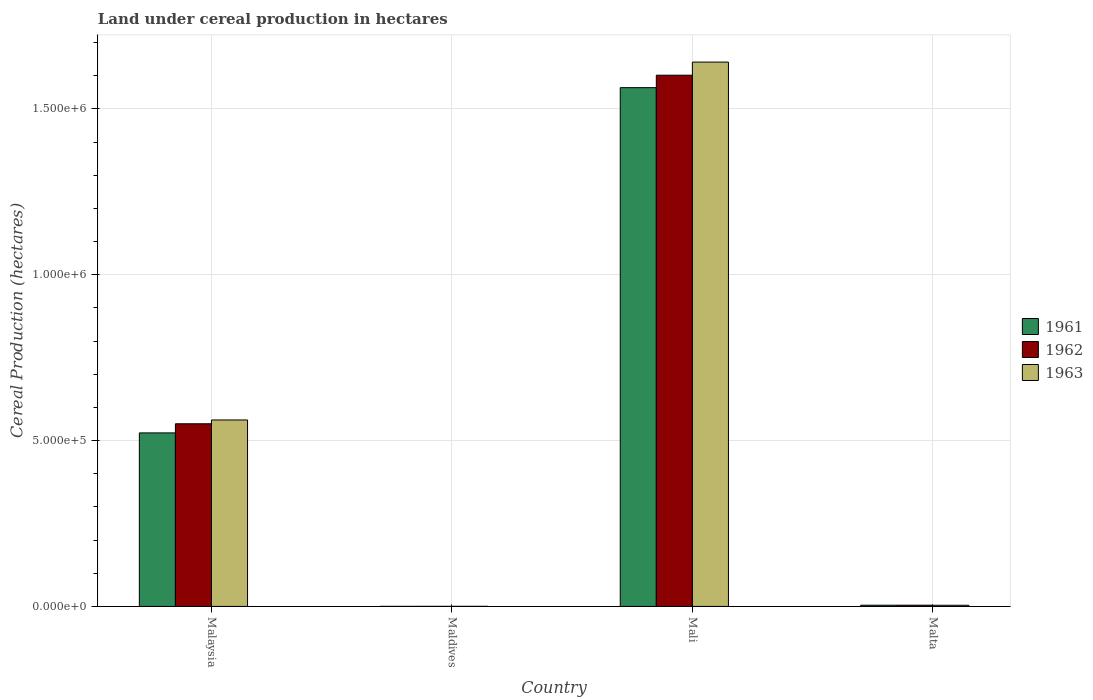Are the number of bars on each tick of the X-axis equal?
Offer a terse response. Yes. How many bars are there on the 3rd tick from the right?
Your answer should be compact. 3. What is the label of the 3rd group of bars from the left?
Make the answer very short. Mali. What is the land under cereal production in 1962 in Mali?
Your answer should be compact. 1.60e+06. Across all countries, what is the maximum land under cereal production in 1963?
Ensure brevity in your answer.  1.64e+06. Across all countries, what is the minimum land under cereal production in 1963?
Offer a very short reply. 292. In which country was the land under cereal production in 1962 maximum?
Offer a terse response. Mali. In which country was the land under cereal production in 1961 minimum?
Offer a terse response. Maldives. What is the total land under cereal production in 1962 in the graph?
Your response must be concise. 2.16e+06. What is the difference between the land under cereal production in 1963 in Malaysia and that in Malta?
Offer a very short reply. 5.59e+05. What is the difference between the land under cereal production in 1961 in Malaysia and the land under cereal production in 1963 in Mali?
Keep it short and to the point. -1.12e+06. What is the average land under cereal production in 1963 per country?
Make the answer very short. 5.52e+05. What is the difference between the land under cereal production of/in 1963 and land under cereal production of/in 1961 in Malaysia?
Provide a succinct answer. 3.90e+04. In how many countries, is the land under cereal production in 1962 greater than 600000 hectares?
Your answer should be very brief. 1. What is the ratio of the land under cereal production in 1961 in Maldives to that in Malta?
Give a very brief answer. 0.05. Is the land under cereal production in 1961 in Malaysia less than that in Mali?
Give a very brief answer. Yes. Is the difference between the land under cereal production in 1963 in Malaysia and Malta greater than the difference between the land under cereal production in 1961 in Malaysia and Malta?
Offer a very short reply. Yes. What is the difference between the highest and the second highest land under cereal production in 1961?
Make the answer very short. -5.20e+05. What is the difference between the highest and the lowest land under cereal production in 1963?
Keep it short and to the point. 1.64e+06. In how many countries, is the land under cereal production in 1961 greater than the average land under cereal production in 1961 taken over all countries?
Offer a terse response. 2. What does the 1st bar from the right in Maldives represents?
Make the answer very short. 1963. Is it the case that in every country, the sum of the land under cereal production in 1963 and land under cereal production in 1962 is greater than the land under cereal production in 1961?
Your answer should be very brief. Yes. Are all the bars in the graph horizontal?
Make the answer very short. No. How many countries are there in the graph?
Ensure brevity in your answer.  4. Does the graph contain any zero values?
Keep it short and to the point. No. How many legend labels are there?
Your response must be concise. 3. What is the title of the graph?
Your answer should be very brief. Land under cereal production in hectares. What is the label or title of the Y-axis?
Offer a very short reply. Cereal Production (hectares). What is the Cereal Production (hectares) of 1961 in Malaysia?
Ensure brevity in your answer.  5.23e+05. What is the Cereal Production (hectares) of 1962 in Malaysia?
Ensure brevity in your answer.  5.51e+05. What is the Cereal Production (hectares) of 1963 in Malaysia?
Offer a terse response. 5.62e+05. What is the Cereal Production (hectares) in 1961 in Maldives?
Give a very brief answer. 179. What is the Cereal Production (hectares) of 1962 in Maldives?
Provide a succinct answer. 240. What is the Cereal Production (hectares) of 1963 in Maldives?
Keep it short and to the point. 292. What is the Cereal Production (hectares) of 1961 in Mali?
Ensure brevity in your answer.  1.56e+06. What is the Cereal Production (hectares) of 1962 in Mali?
Give a very brief answer. 1.60e+06. What is the Cereal Production (hectares) in 1963 in Mali?
Keep it short and to the point. 1.64e+06. What is the Cereal Production (hectares) in 1961 in Malta?
Your response must be concise. 3649. What is the Cereal Production (hectares) of 1962 in Malta?
Your response must be concise. 3699. What is the Cereal Production (hectares) of 1963 in Malta?
Give a very brief answer. 3513. Across all countries, what is the maximum Cereal Production (hectares) in 1961?
Provide a succinct answer. 1.56e+06. Across all countries, what is the maximum Cereal Production (hectares) in 1962?
Offer a terse response. 1.60e+06. Across all countries, what is the maximum Cereal Production (hectares) in 1963?
Provide a short and direct response. 1.64e+06. Across all countries, what is the minimum Cereal Production (hectares) in 1961?
Your answer should be compact. 179. Across all countries, what is the minimum Cereal Production (hectares) of 1962?
Offer a very short reply. 240. Across all countries, what is the minimum Cereal Production (hectares) in 1963?
Offer a very short reply. 292. What is the total Cereal Production (hectares) of 1961 in the graph?
Your response must be concise. 2.09e+06. What is the total Cereal Production (hectares) of 1962 in the graph?
Make the answer very short. 2.16e+06. What is the total Cereal Production (hectares) in 1963 in the graph?
Your answer should be compact. 2.21e+06. What is the difference between the Cereal Production (hectares) in 1961 in Malaysia and that in Maldives?
Provide a succinct answer. 5.23e+05. What is the difference between the Cereal Production (hectares) in 1962 in Malaysia and that in Maldives?
Make the answer very short. 5.50e+05. What is the difference between the Cereal Production (hectares) of 1963 in Malaysia and that in Maldives?
Your answer should be very brief. 5.62e+05. What is the difference between the Cereal Production (hectares) of 1961 in Malaysia and that in Mali?
Offer a terse response. -1.04e+06. What is the difference between the Cereal Production (hectares) of 1962 in Malaysia and that in Mali?
Your answer should be very brief. -1.05e+06. What is the difference between the Cereal Production (hectares) of 1963 in Malaysia and that in Mali?
Your answer should be very brief. -1.08e+06. What is the difference between the Cereal Production (hectares) in 1961 in Malaysia and that in Malta?
Your answer should be very brief. 5.20e+05. What is the difference between the Cereal Production (hectares) of 1962 in Malaysia and that in Malta?
Offer a very short reply. 5.47e+05. What is the difference between the Cereal Production (hectares) in 1963 in Malaysia and that in Malta?
Keep it short and to the point. 5.59e+05. What is the difference between the Cereal Production (hectares) of 1961 in Maldives and that in Mali?
Keep it short and to the point. -1.56e+06. What is the difference between the Cereal Production (hectares) in 1962 in Maldives and that in Mali?
Offer a very short reply. -1.60e+06. What is the difference between the Cereal Production (hectares) of 1963 in Maldives and that in Mali?
Offer a terse response. -1.64e+06. What is the difference between the Cereal Production (hectares) in 1961 in Maldives and that in Malta?
Ensure brevity in your answer.  -3470. What is the difference between the Cereal Production (hectares) in 1962 in Maldives and that in Malta?
Your response must be concise. -3459. What is the difference between the Cereal Production (hectares) in 1963 in Maldives and that in Malta?
Your answer should be very brief. -3221. What is the difference between the Cereal Production (hectares) of 1961 in Mali and that in Malta?
Provide a short and direct response. 1.56e+06. What is the difference between the Cereal Production (hectares) in 1962 in Mali and that in Malta?
Give a very brief answer. 1.60e+06. What is the difference between the Cereal Production (hectares) of 1963 in Mali and that in Malta?
Your response must be concise. 1.64e+06. What is the difference between the Cereal Production (hectares) of 1961 in Malaysia and the Cereal Production (hectares) of 1962 in Maldives?
Provide a short and direct response. 5.23e+05. What is the difference between the Cereal Production (hectares) of 1961 in Malaysia and the Cereal Production (hectares) of 1963 in Maldives?
Your answer should be compact. 5.23e+05. What is the difference between the Cereal Production (hectares) in 1962 in Malaysia and the Cereal Production (hectares) in 1963 in Maldives?
Your response must be concise. 5.50e+05. What is the difference between the Cereal Production (hectares) in 1961 in Malaysia and the Cereal Production (hectares) in 1962 in Mali?
Keep it short and to the point. -1.08e+06. What is the difference between the Cereal Production (hectares) in 1961 in Malaysia and the Cereal Production (hectares) in 1963 in Mali?
Your response must be concise. -1.12e+06. What is the difference between the Cereal Production (hectares) of 1962 in Malaysia and the Cereal Production (hectares) of 1963 in Mali?
Your response must be concise. -1.09e+06. What is the difference between the Cereal Production (hectares) in 1961 in Malaysia and the Cereal Production (hectares) in 1962 in Malta?
Offer a terse response. 5.19e+05. What is the difference between the Cereal Production (hectares) in 1961 in Malaysia and the Cereal Production (hectares) in 1963 in Malta?
Ensure brevity in your answer.  5.20e+05. What is the difference between the Cereal Production (hectares) in 1962 in Malaysia and the Cereal Production (hectares) in 1963 in Malta?
Your response must be concise. 5.47e+05. What is the difference between the Cereal Production (hectares) in 1961 in Maldives and the Cereal Production (hectares) in 1962 in Mali?
Offer a terse response. -1.60e+06. What is the difference between the Cereal Production (hectares) in 1961 in Maldives and the Cereal Production (hectares) in 1963 in Mali?
Keep it short and to the point. -1.64e+06. What is the difference between the Cereal Production (hectares) in 1962 in Maldives and the Cereal Production (hectares) in 1963 in Mali?
Your answer should be very brief. -1.64e+06. What is the difference between the Cereal Production (hectares) of 1961 in Maldives and the Cereal Production (hectares) of 1962 in Malta?
Offer a very short reply. -3520. What is the difference between the Cereal Production (hectares) in 1961 in Maldives and the Cereal Production (hectares) in 1963 in Malta?
Your response must be concise. -3334. What is the difference between the Cereal Production (hectares) in 1962 in Maldives and the Cereal Production (hectares) in 1963 in Malta?
Keep it short and to the point. -3273. What is the difference between the Cereal Production (hectares) of 1961 in Mali and the Cereal Production (hectares) of 1962 in Malta?
Your response must be concise. 1.56e+06. What is the difference between the Cereal Production (hectares) in 1961 in Mali and the Cereal Production (hectares) in 1963 in Malta?
Ensure brevity in your answer.  1.56e+06. What is the difference between the Cereal Production (hectares) in 1962 in Mali and the Cereal Production (hectares) in 1963 in Malta?
Your answer should be very brief. 1.60e+06. What is the average Cereal Production (hectares) of 1961 per country?
Give a very brief answer. 5.23e+05. What is the average Cereal Production (hectares) in 1962 per country?
Offer a very short reply. 5.39e+05. What is the average Cereal Production (hectares) in 1963 per country?
Offer a terse response. 5.52e+05. What is the difference between the Cereal Production (hectares) in 1961 and Cereal Production (hectares) in 1962 in Malaysia?
Your response must be concise. -2.75e+04. What is the difference between the Cereal Production (hectares) of 1961 and Cereal Production (hectares) of 1963 in Malaysia?
Ensure brevity in your answer.  -3.90e+04. What is the difference between the Cereal Production (hectares) of 1962 and Cereal Production (hectares) of 1963 in Malaysia?
Provide a short and direct response. -1.15e+04. What is the difference between the Cereal Production (hectares) in 1961 and Cereal Production (hectares) in 1962 in Maldives?
Provide a succinct answer. -61. What is the difference between the Cereal Production (hectares) in 1961 and Cereal Production (hectares) in 1963 in Maldives?
Offer a terse response. -113. What is the difference between the Cereal Production (hectares) in 1962 and Cereal Production (hectares) in 1963 in Maldives?
Offer a very short reply. -52. What is the difference between the Cereal Production (hectares) of 1961 and Cereal Production (hectares) of 1962 in Mali?
Make the answer very short. -3.75e+04. What is the difference between the Cereal Production (hectares) in 1961 and Cereal Production (hectares) in 1963 in Mali?
Provide a succinct answer. -7.71e+04. What is the difference between the Cereal Production (hectares) of 1962 and Cereal Production (hectares) of 1963 in Mali?
Ensure brevity in your answer.  -3.96e+04. What is the difference between the Cereal Production (hectares) in 1961 and Cereal Production (hectares) in 1963 in Malta?
Your response must be concise. 136. What is the difference between the Cereal Production (hectares) of 1962 and Cereal Production (hectares) of 1963 in Malta?
Ensure brevity in your answer.  186. What is the ratio of the Cereal Production (hectares) in 1961 in Malaysia to that in Maldives?
Offer a very short reply. 2922.64. What is the ratio of the Cereal Production (hectares) in 1962 in Malaysia to that in Maldives?
Give a very brief answer. 2294.52. What is the ratio of the Cereal Production (hectares) in 1963 in Malaysia to that in Maldives?
Offer a very short reply. 1925.29. What is the ratio of the Cereal Production (hectares) in 1961 in Malaysia to that in Mali?
Offer a very short reply. 0.33. What is the ratio of the Cereal Production (hectares) of 1962 in Malaysia to that in Mali?
Keep it short and to the point. 0.34. What is the ratio of the Cereal Production (hectares) of 1963 in Malaysia to that in Mali?
Keep it short and to the point. 0.34. What is the ratio of the Cereal Production (hectares) in 1961 in Malaysia to that in Malta?
Offer a very short reply. 143.37. What is the ratio of the Cereal Production (hectares) of 1962 in Malaysia to that in Malta?
Make the answer very short. 148.87. What is the ratio of the Cereal Production (hectares) of 1963 in Malaysia to that in Malta?
Your response must be concise. 160.03. What is the ratio of the Cereal Production (hectares) of 1961 in Maldives to that in Mali?
Make the answer very short. 0. What is the ratio of the Cereal Production (hectares) of 1963 in Maldives to that in Mali?
Offer a terse response. 0. What is the ratio of the Cereal Production (hectares) of 1961 in Maldives to that in Malta?
Keep it short and to the point. 0.05. What is the ratio of the Cereal Production (hectares) in 1962 in Maldives to that in Malta?
Your answer should be very brief. 0.06. What is the ratio of the Cereal Production (hectares) in 1963 in Maldives to that in Malta?
Offer a very short reply. 0.08. What is the ratio of the Cereal Production (hectares) in 1961 in Mali to that in Malta?
Your answer should be very brief. 428.61. What is the ratio of the Cereal Production (hectares) of 1962 in Mali to that in Malta?
Make the answer very short. 432.95. What is the ratio of the Cereal Production (hectares) of 1963 in Mali to that in Malta?
Offer a very short reply. 467.14. What is the difference between the highest and the second highest Cereal Production (hectares) in 1961?
Make the answer very short. 1.04e+06. What is the difference between the highest and the second highest Cereal Production (hectares) in 1962?
Give a very brief answer. 1.05e+06. What is the difference between the highest and the second highest Cereal Production (hectares) in 1963?
Provide a succinct answer. 1.08e+06. What is the difference between the highest and the lowest Cereal Production (hectares) in 1961?
Make the answer very short. 1.56e+06. What is the difference between the highest and the lowest Cereal Production (hectares) in 1962?
Keep it short and to the point. 1.60e+06. What is the difference between the highest and the lowest Cereal Production (hectares) of 1963?
Keep it short and to the point. 1.64e+06. 